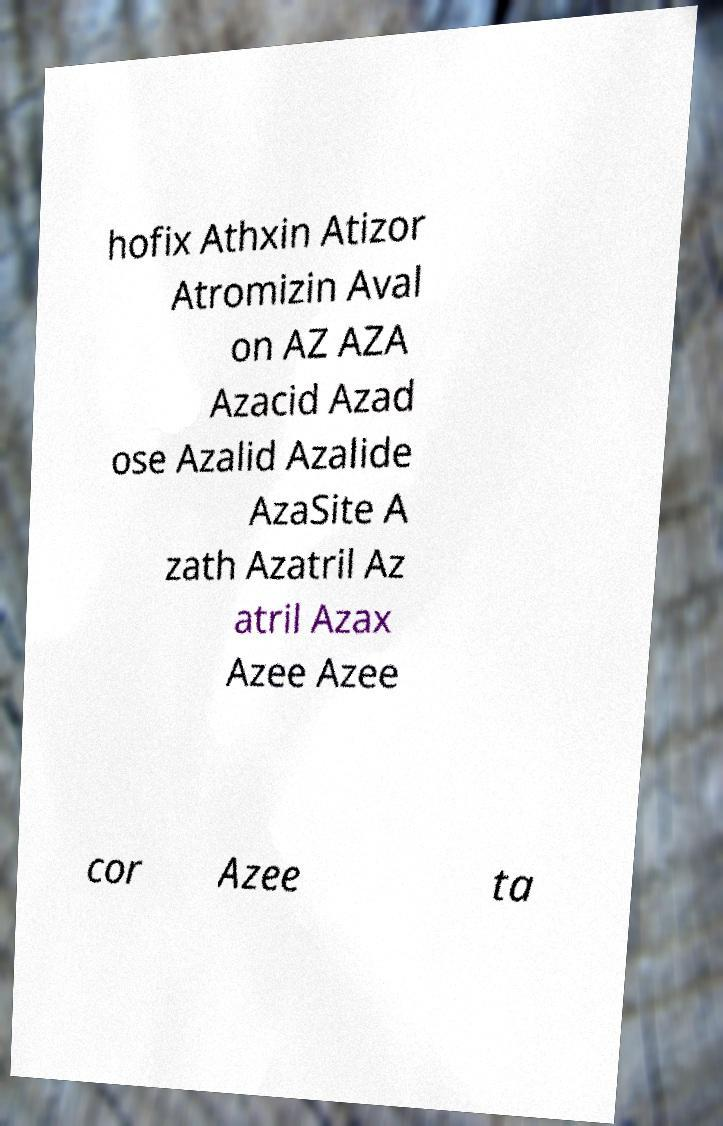For documentation purposes, I need the text within this image transcribed. Could you provide that? hofix Athxin Atizor Atromizin Aval on AZ AZA Azacid Azad ose Azalid Azalide AzaSite A zath Azatril Az atril Azax Azee Azee cor Azee ta 